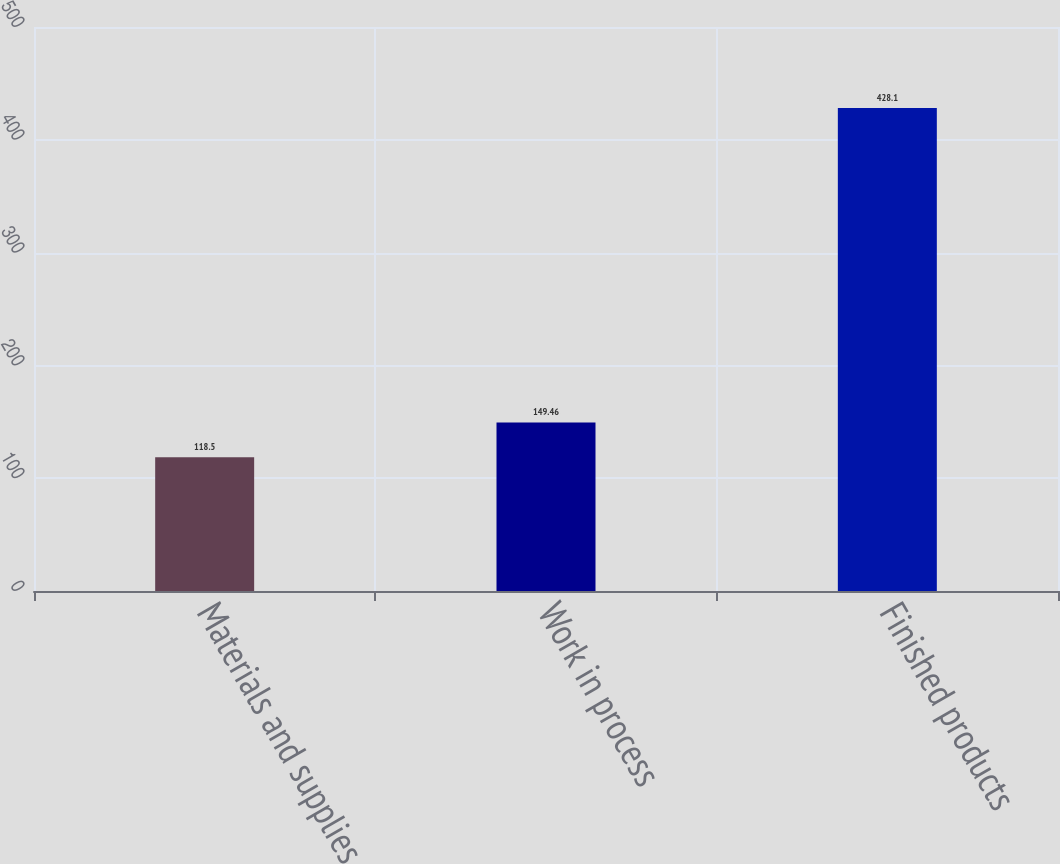Convert chart to OTSL. <chart><loc_0><loc_0><loc_500><loc_500><bar_chart><fcel>Materials and supplies<fcel>Work in process<fcel>Finished products<nl><fcel>118.5<fcel>149.46<fcel>428.1<nl></chart> 